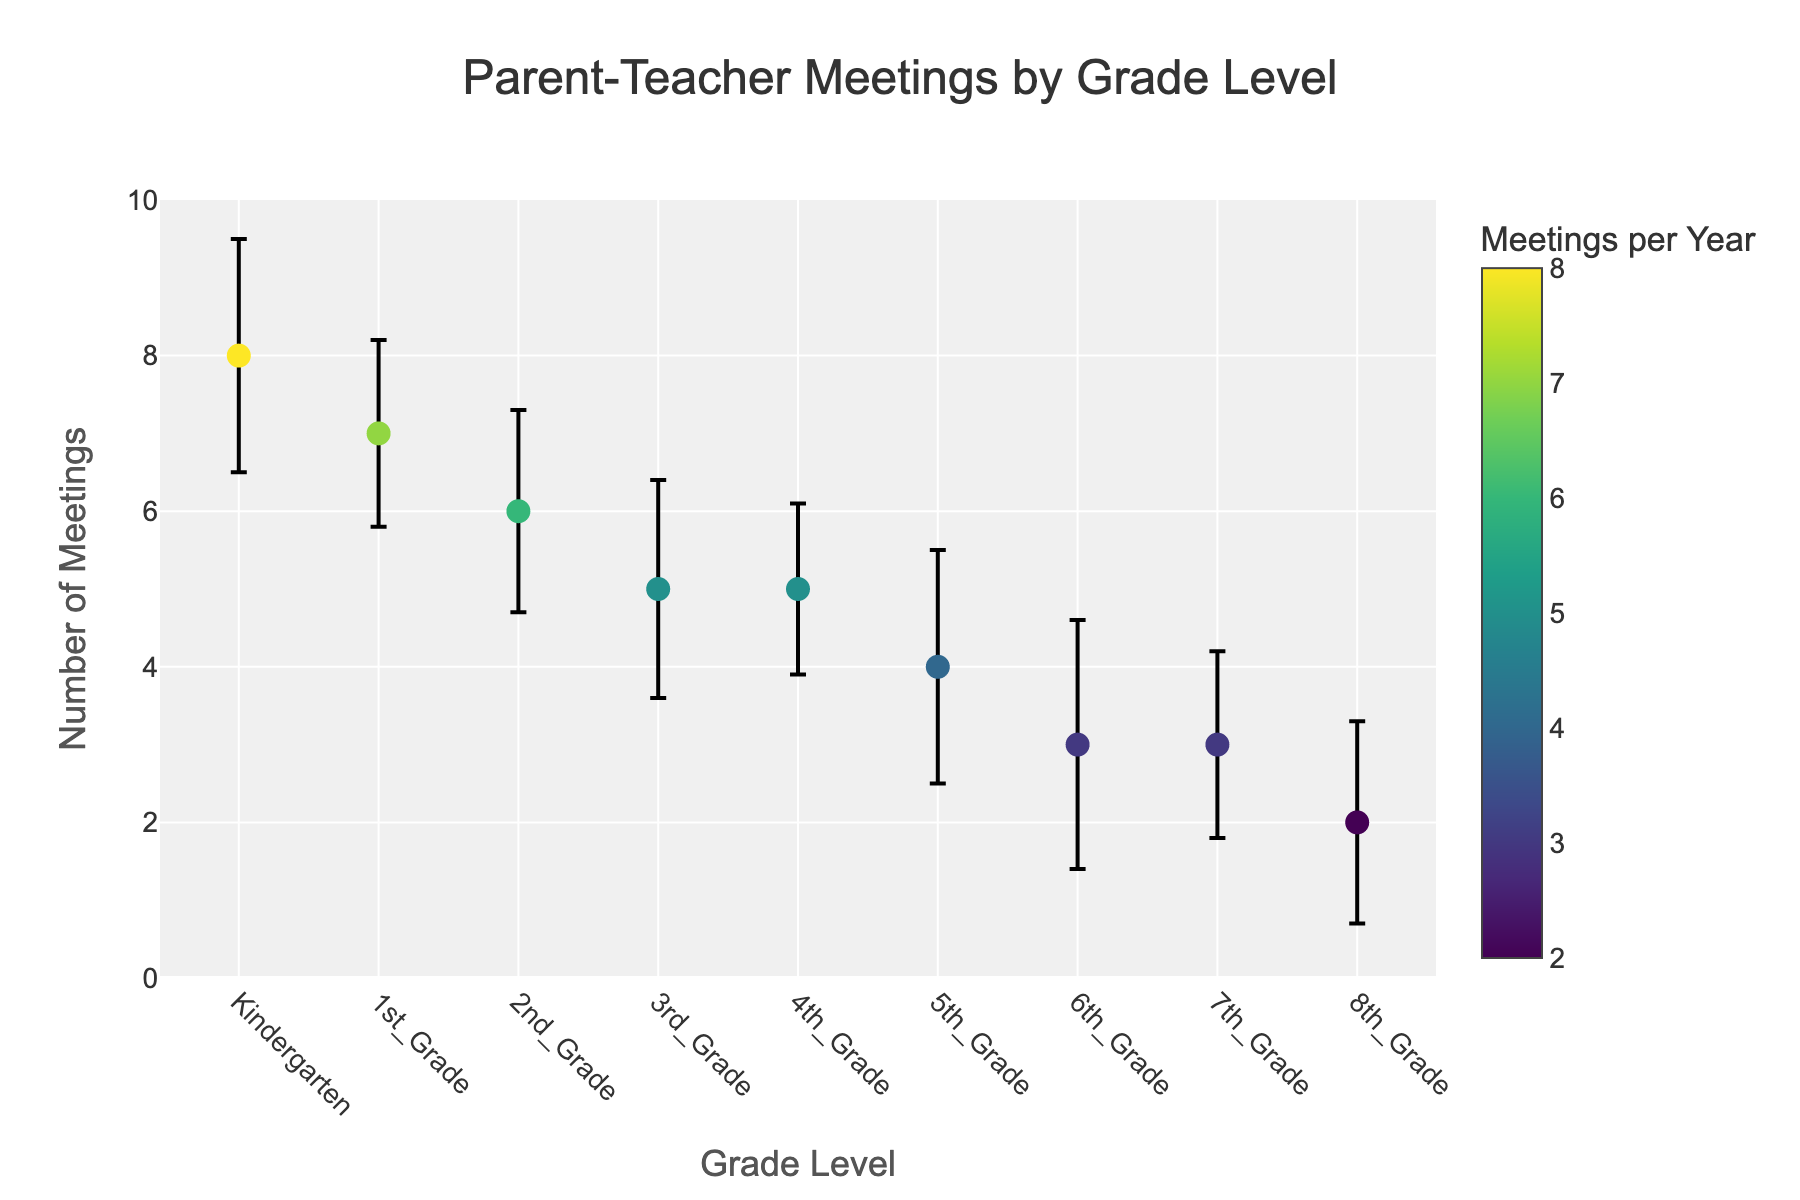What's the title of the figure? The title of the figure is generally located at the top center and is clearly visible. By reading the top of the plot, the title states 'Parent-Teacher Meetings by Grade Level'.
Answer: Parent-Teacher Meetings by Grade Level What are the y-axis and x-axis labels? The labels for the axes are usually located next to the axes. By locating and reading the labels, the x-axis is labeled 'Grade Level', and the y-axis is labeled 'Number of Meetings'.
Answer: Grade Level (x) and Number of Meetings (y) How many meetings per year are there for Kindergarten? Look at the dot corresponding to Kindergarten on the x-axis and find the y-coordinate. The dot for Kindergarten is at the 8 on the y-axis.
Answer: 8 Which grade has the highest standard deviation for the number of meetings per year? The standard deviation is represented by the length of the error bar. By comparing the lengths, 6th Grade has the longest error bar.
Answer: 6th Grade What is the difference between the number of meetings per year for 1st Grade and 3rd Grade? First, locate the dots for 1st Grade and 3rd Grade. 1st Grade is at 7 meetings per year while 3rd Grade is at 5 meetings per year. Subtract 5 from 7.
Answer: 2 How does the number of meetings per year change from Kindergarten to 8th Grade? Identify the pattern by comparing the dots for Kindergarten and 8th Grade. The number of meetings per year decreases gradually from left to right.
Answer: It decreases Which grade has the lowest number of parent-teacher meetings per year? Locate the dot with the lowest y-coordinate. The lowest dot is for 8th Grade at 2 meetings per year.
Answer: 8th Grade What is the range of the number of meetings across all grades? The range is calculated by subtracting the smallest value from the largest value. The smallest value is 2 (8th Grade), and the largest is 8 (Kindergarten). So, 8 - 2.
Answer: 6 What is the average number of parent-teacher meetings across all grades? Sum all the meeting counts and divide by the number of grades. The total is 8 + 7 + 6 + 5 + 5 + 4 + 3 + 3 + 2 = 43. Divide by 9 grades.
Answer: 4.78 